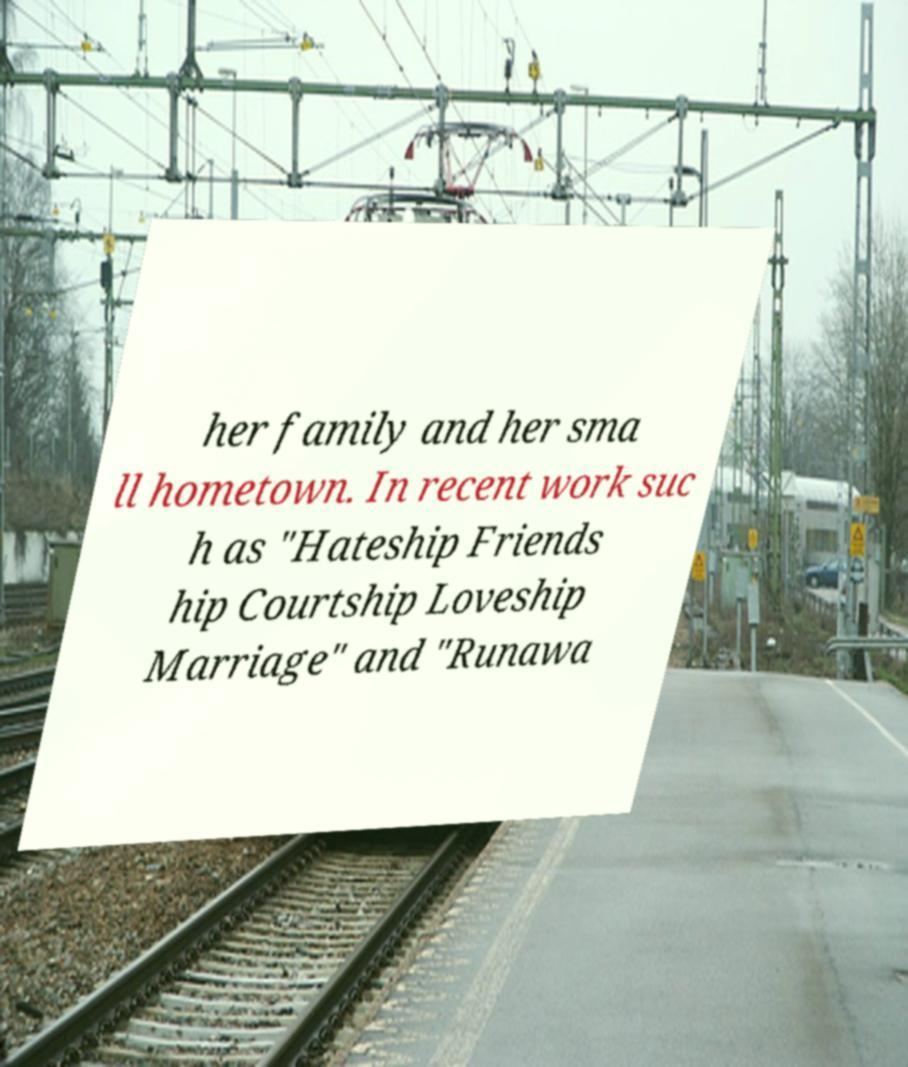Could you assist in decoding the text presented in this image and type it out clearly? her family and her sma ll hometown. In recent work suc h as "Hateship Friends hip Courtship Loveship Marriage" and "Runawa 